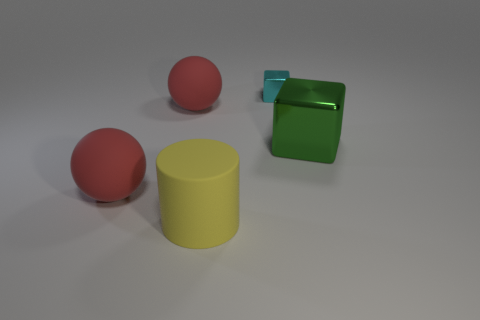What number of balls are green things or red matte things?
Offer a very short reply. 2. Are there any tiny yellow blocks?
Your response must be concise. No. Is there any other thing that has the same shape as the large green shiny object?
Ensure brevity in your answer.  Yes. Does the rubber cylinder have the same color as the large shiny block?
Offer a terse response. No. How many things are rubber spheres in front of the green cube or tiny metallic cubes?
Offer a terse response. 2. How many big balls are to the right of the red ball in front of the metal cube that is right of the cyan object?
Provide a short and direct response. 1. Is there anything else that is the same size as the yellow cylinder?
Ensure brevity in your answer.  Yes. The large object that is to the right of the large thing in front of the large red rubber object that is in front of the green metallic object is what shape?
Your response must be concise. Cube. What number of other things are the same color as the cylinder?
Provide a succinct answer. 0. The shiny thing that is behind the large object on the right side of the large cylinder is what shape?
Give a very brief answer. Cube. 